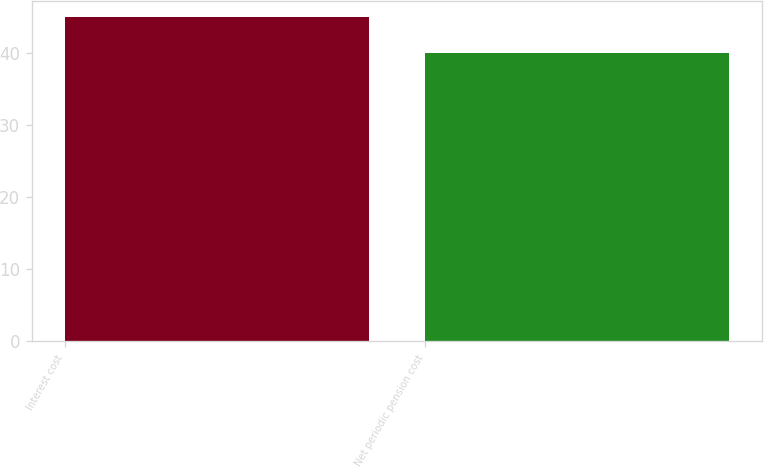<chart> <loc_0><loc_0><loc_500><loc_500><bar_chart><fcel>Interest cost<fcel>Net periodic pension cost<nl><fcel>45<fcel>40<nl></chart> 